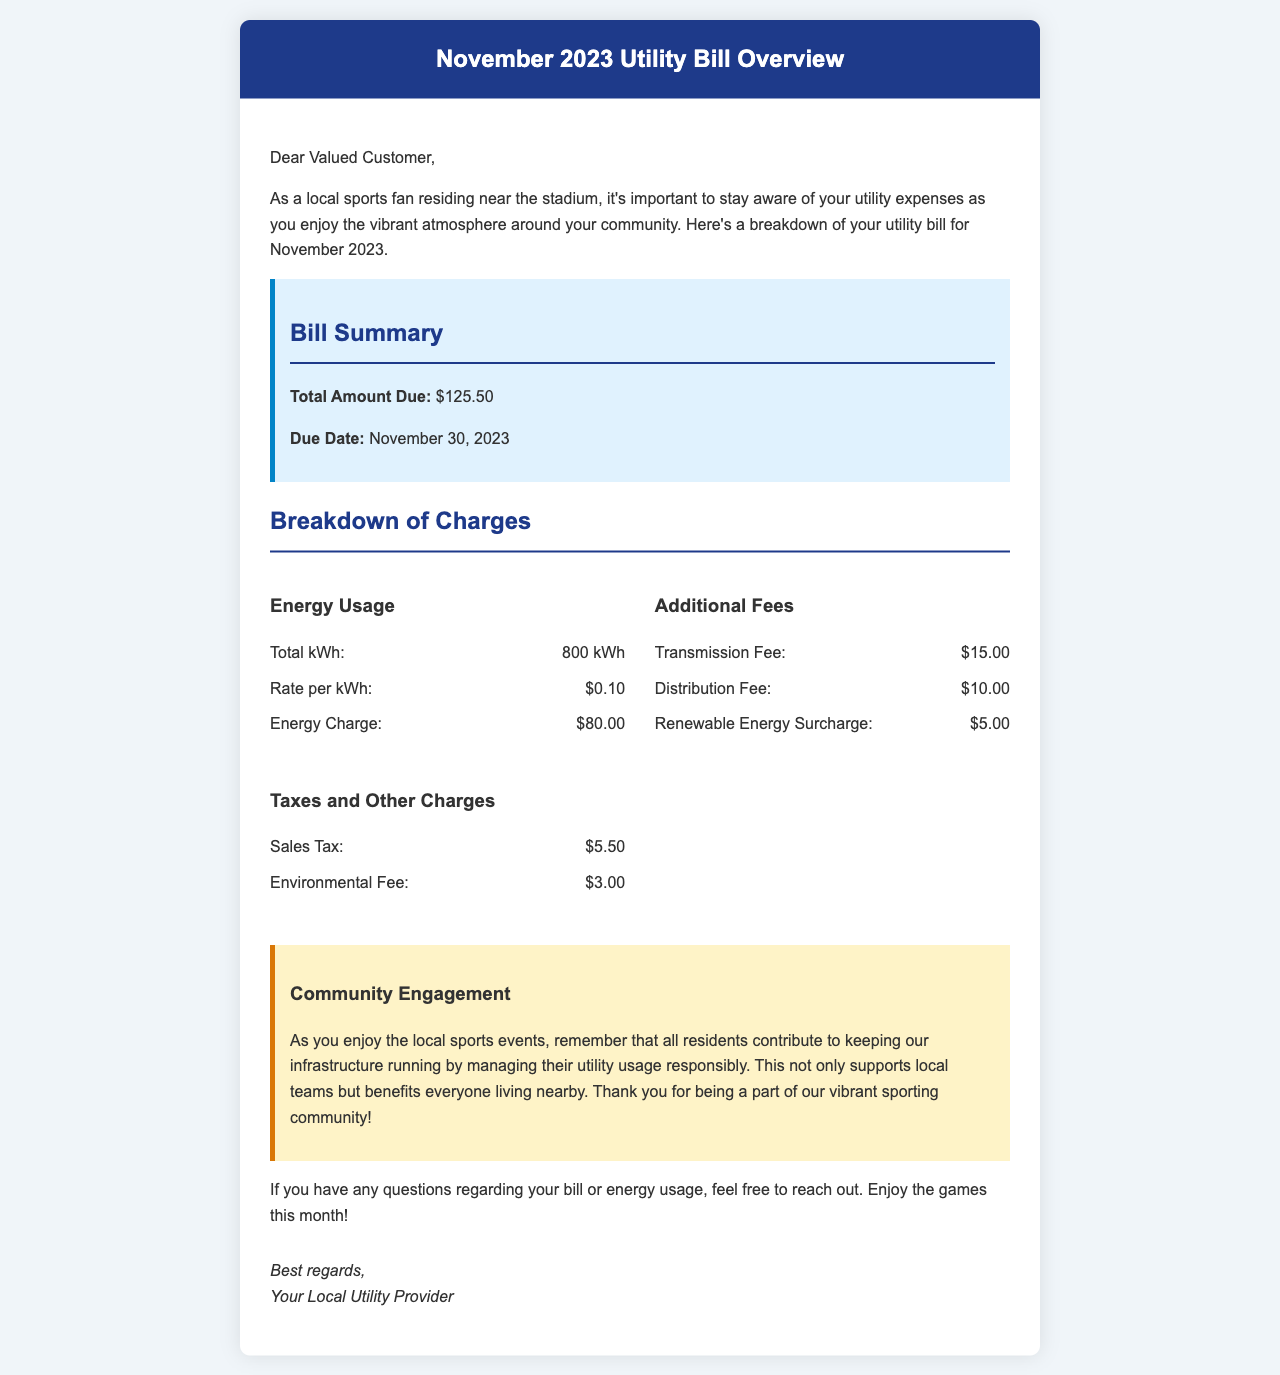What is the total amount due? The total amount due is stated in the bill summary section of the document.
Answer: $125.50 When is the due date for the bill? The due date for the bill is mentioned in the bill summary section of the document.
Answer: November 30, 2023 How many kilowatt-hours were used? The total energy usage (kWh) is specified in the energy usage section of the document.
Answer: 800 kWh What is the rate per kilowatt-hour? The rate per kWh is explicitly stated in the energy usage section of the document.
Answer: $0.10 What is the total energy charge? The total energy charge is provided in the energy usage section.
Answer: $80.00 What is the transmission fee? The transmission fee is listed in the additional fees section of the document.
Answer: $15.00 What is the sales tax amount? The sales tax amount is found in the taxes and other charges section of the document.
Answer: $5.50 What type of engagement is encouraged in the community? The document discusses community engagement relating to responsible utility usage.
Answer: Responsible utility usage Why is it important to manage utility usage? The document explains that managing usage benefits the local community and sports infrastructure.
Answer: Supports local teams and benefits everyone living nearby 